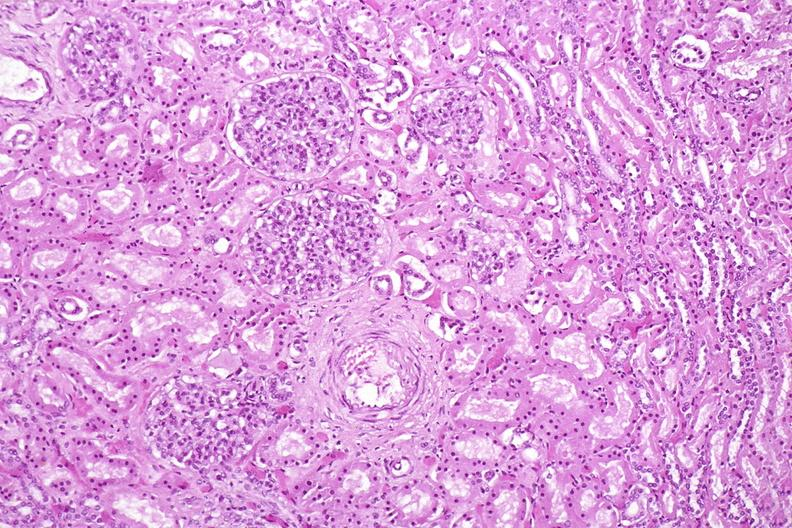where is this?
Answer the question using a single word or phrase. Urinary 